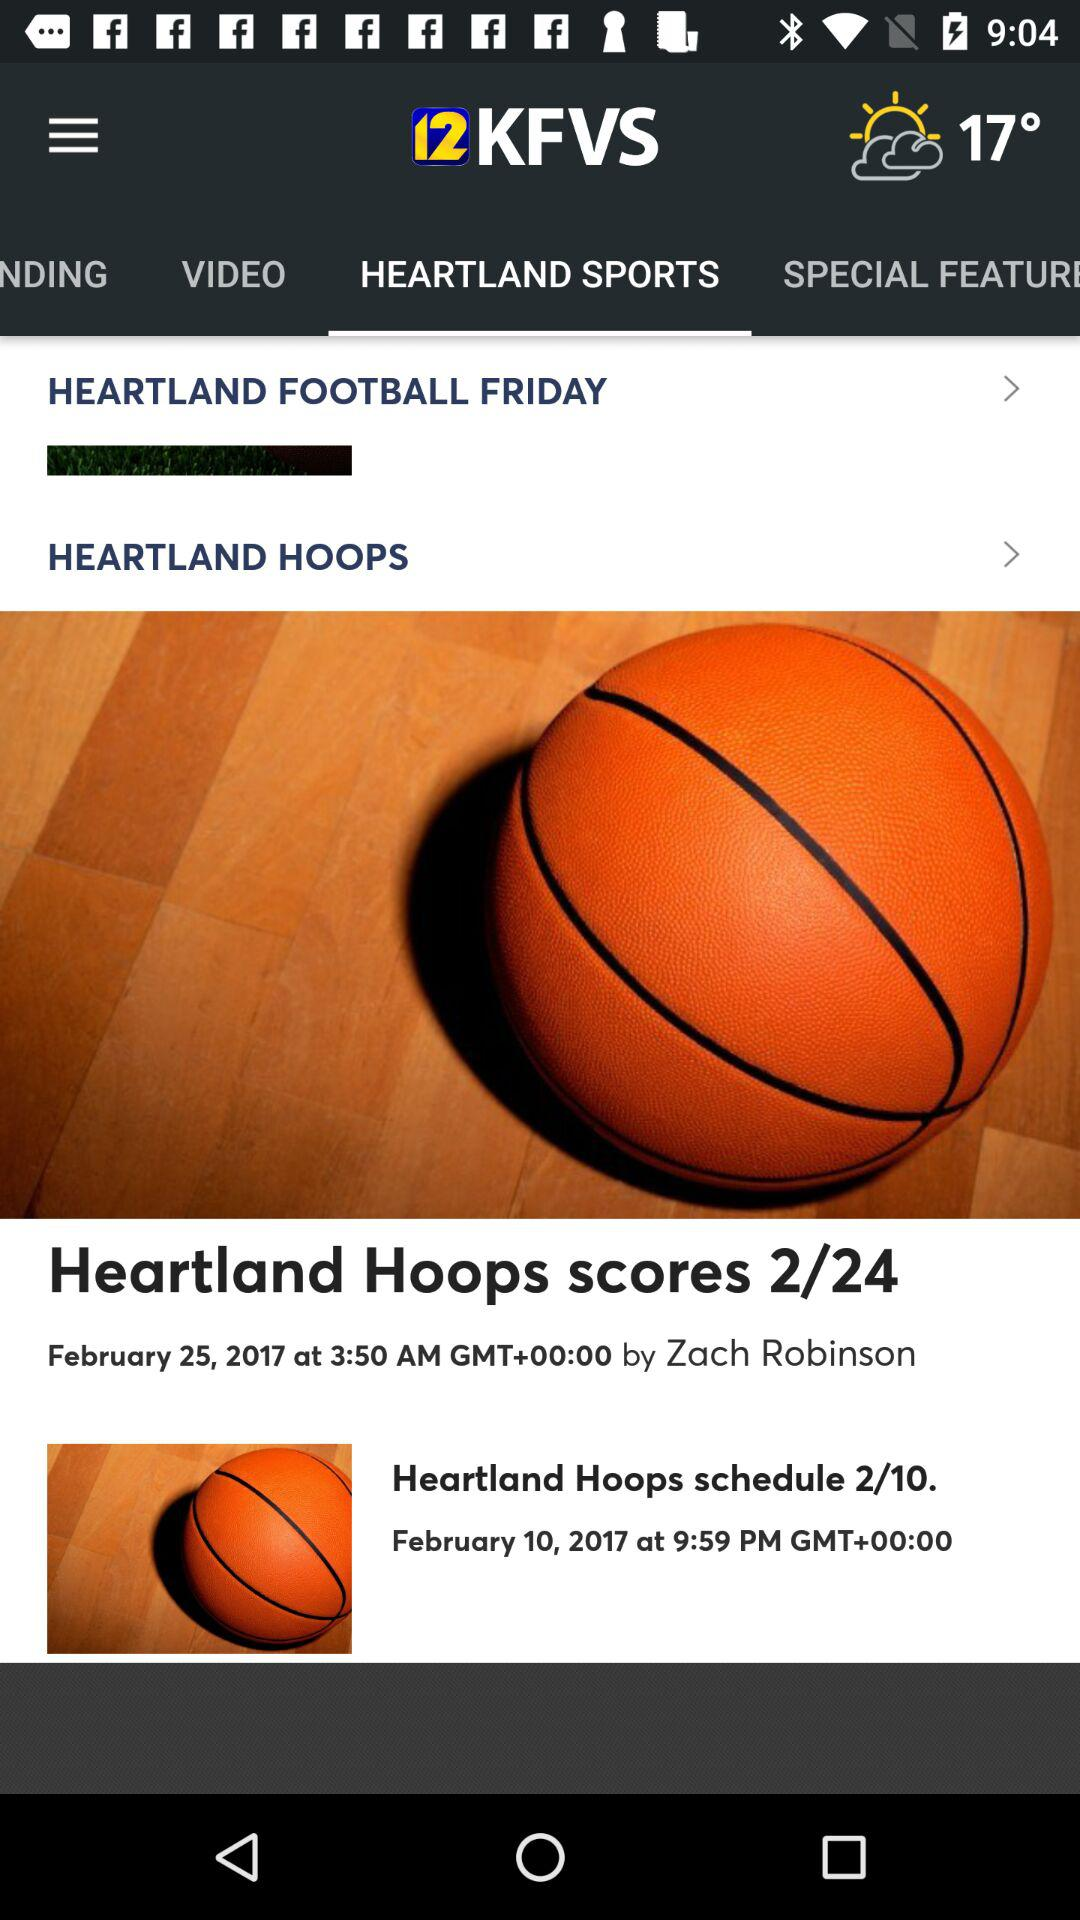What is the name of the application? The name of the application is "12KFVS". 